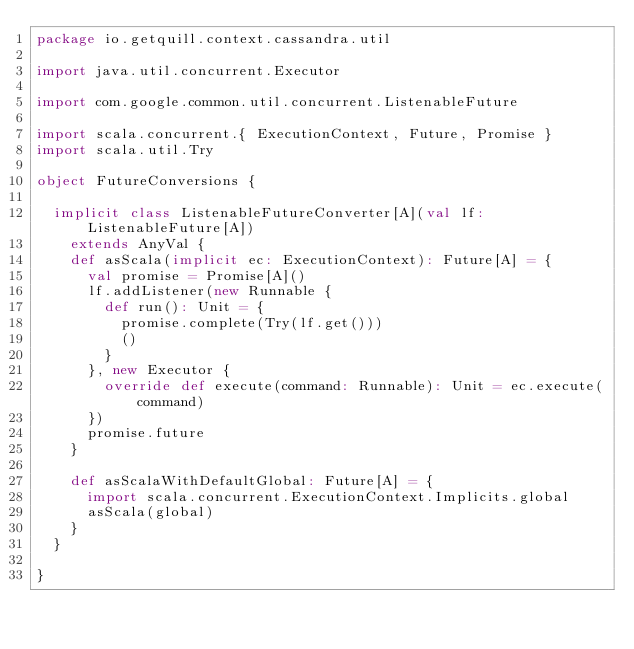<code> <loc_0><loc_0><loc_500><loc_500><_Scala_>package io.getquill.context.cassandra.util

import java.util.concurrent.Executor

import com.google.common.util.concurrent.ListenableFuture

import scala.concurrent.{ ExecutionContext, Future, Promise }
import scala.util.Try

object FutureConversions {

  implicit class ListenableFutureConverter[A](val lf: ListenableFuture[A])
    extends AnyVal {
    def asScala(implicit ec: ExecutionContext): Future[A] = {
      val promise = Promise[A]()
      lf.addListener(new Runnable {
        def run(): Unit = {
          promise.complete(Try(lf.get()))
          ()
        }
      }, new Executor {
        override def execute(command: Runnable): Unit = ec.execute(command)
      })
      promise.future
    }

    def asScalaWithDefaultGlobal: Future[A] = {
      import scala.concurrent.ExecutionContext.Implicits.global
      asScala(global)
    }
  }

}
</code> 